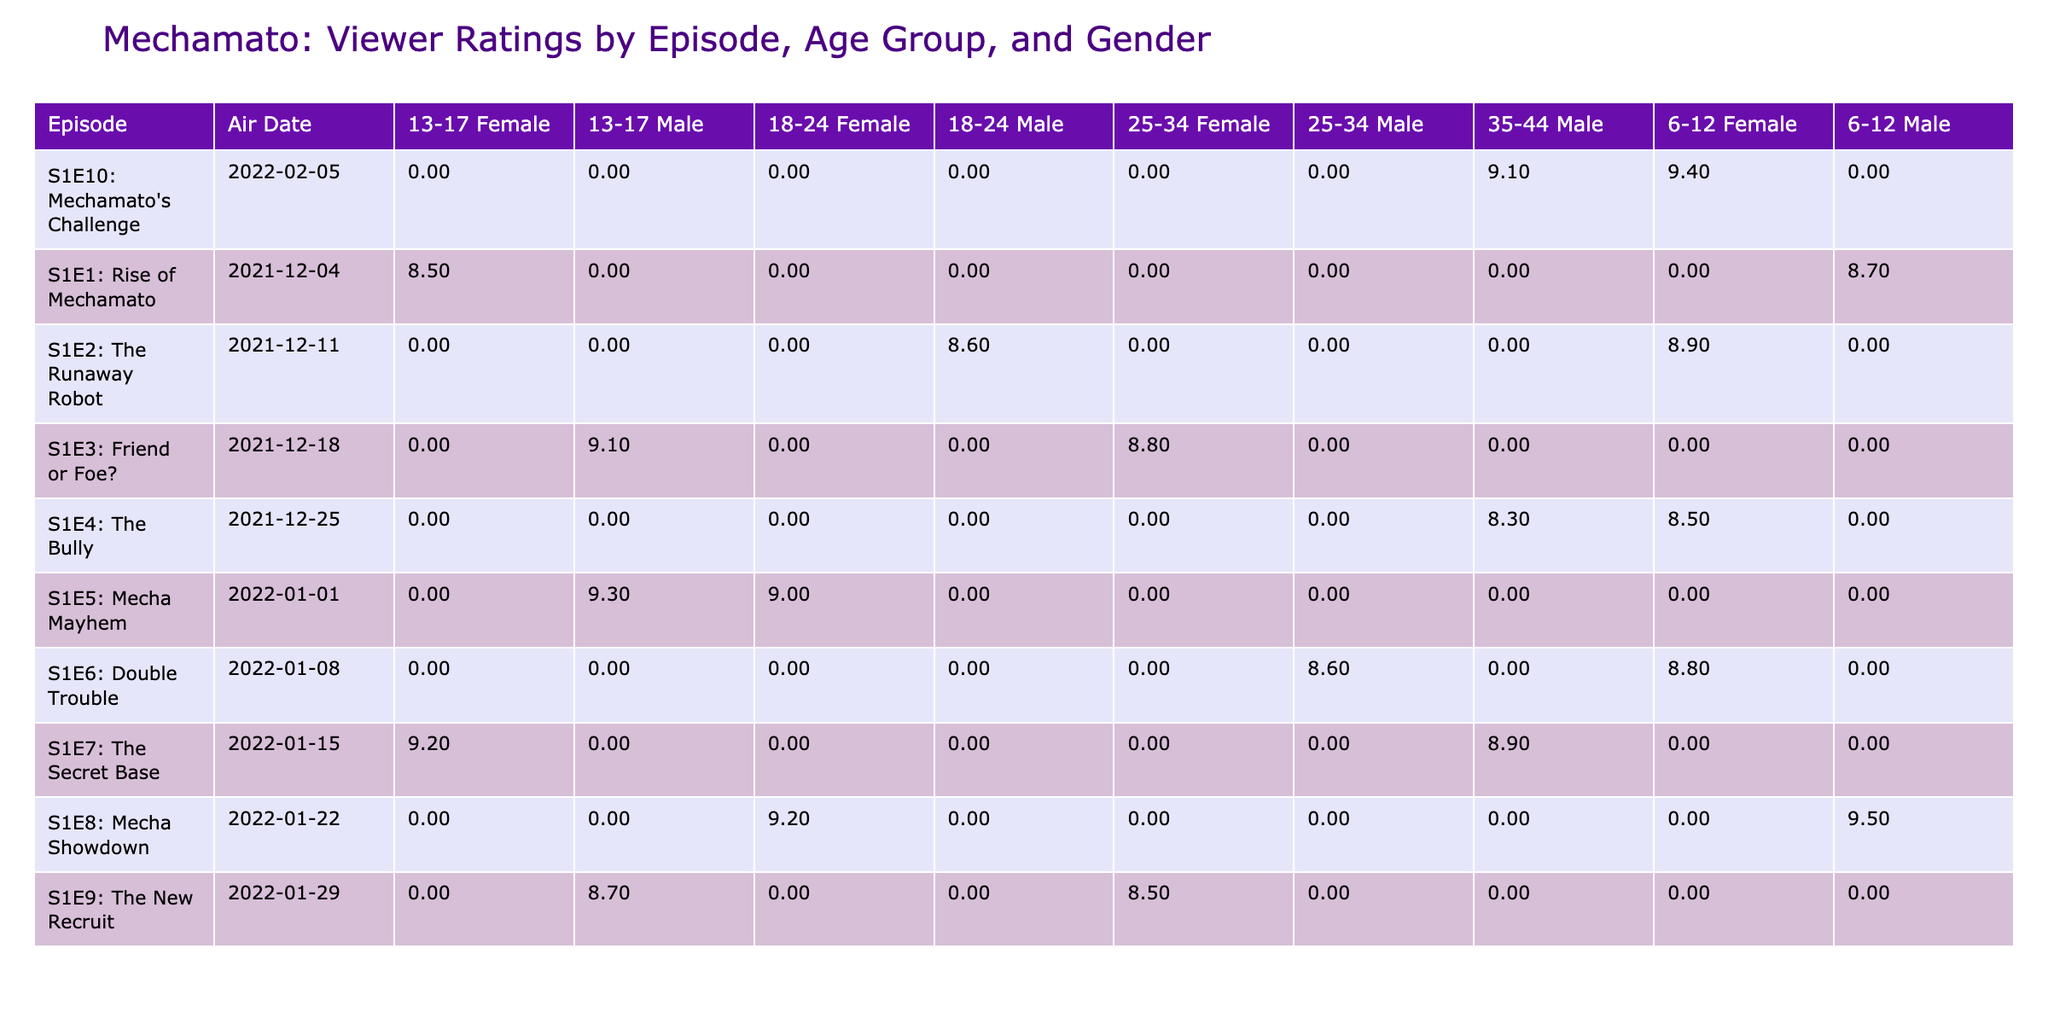What was the viewer rating for "The Bully" among 6-12 year old females? The table shows that for "The Bully," the viewer rating for the age group 6-12 and gender female is 8.5.
Answer: 8.5 What is the average viewer rating from the 13-17 age group across all episodes? To find the average, we look at the viewer ratings for the 13-17 age group which are 8.5, 9.1, 9.3, 9.2, and 8.7. Summing these gives 8.5 + 9.1 + 9.3 + 9.2 + 8.7 = 44.8. There are 5 data points, so the average is 44.8 / 5 = 8.96.
Answer: 8.96 Was "Mecha Mayhem" rated higher by 18-24 year old females or by 25-34 year old males? For "Mecha Mayhem," the viewer rating is 9.0 for 18-24 year old females and 8.6 for 25-34 year old males. Since 9.0 is greater than 8.6, the female rating is higher.
Answer: Yes Which episode had the highest viewer rating and what was that rating? The table indicates that "Mecha Showdown" has the highest viewer rating of 9.5.
Answer: 9.5 How many episodes received a rating of 9.0 or higher among 13-17 year old males? The episodes with a rating of 9.0 or higher for 13-17 year old males are "Friend or Foe?" (9.1), "Mecha Mayhem" (9.3), and "The Secret Base" (9.2). This results in a total of 3 episodes.
Answer: 3 What was the average viewer rating for episodes aired in December 2021? The episodes aired in December 2021 are S1E1 (8.7), S1E2 (8.9), S1E3 (9.1), and S1E4 (8.5). Adding these ratings gives 8.7 + 8.9 + 9.1 + 8.5 = 35.2. The total number of episodes is 4, so the average is 35.2 / 4 = 8.8.
Answer: 8.8 Did more male viewers favor "Amato" or "MechaBot" as their favorite character in the episodes? For episodes, male viewers favoring "Amato" are S1E3 (9.1), S1E4 (8.3), S1E8 (9.2), and S1E9 (8.5), totaling 3 ratings. For "MechaBot," the episodes are S1E1 (8.7), S1E2 (8.6), S1E5 (9.3), S1E6 (8.6), S1E7 (8.9), with a total of 5 ratings. Hence, more male viewers favor "MechaBot."
Answer: No Which age group and gender combination had the lowest viewer rating for "The Runaway Robot"? "The Runaway Robot" has viewer ratings of 8.9 for 6-12 year old females and 8.6 for 18-24 year old males, and thus the lowest rating of 8.6 is for the 18-24 year old male group.
Answer: 18-24 Male How many different countries' viewers are represented in the ratings for "Mechamato's Challenge"? The ratings for "Mechamato's Challenge" include viewers from Malaysia (9.4) and Indonesia (9.1), representing a total of 2 different countries.
Answer: 2 